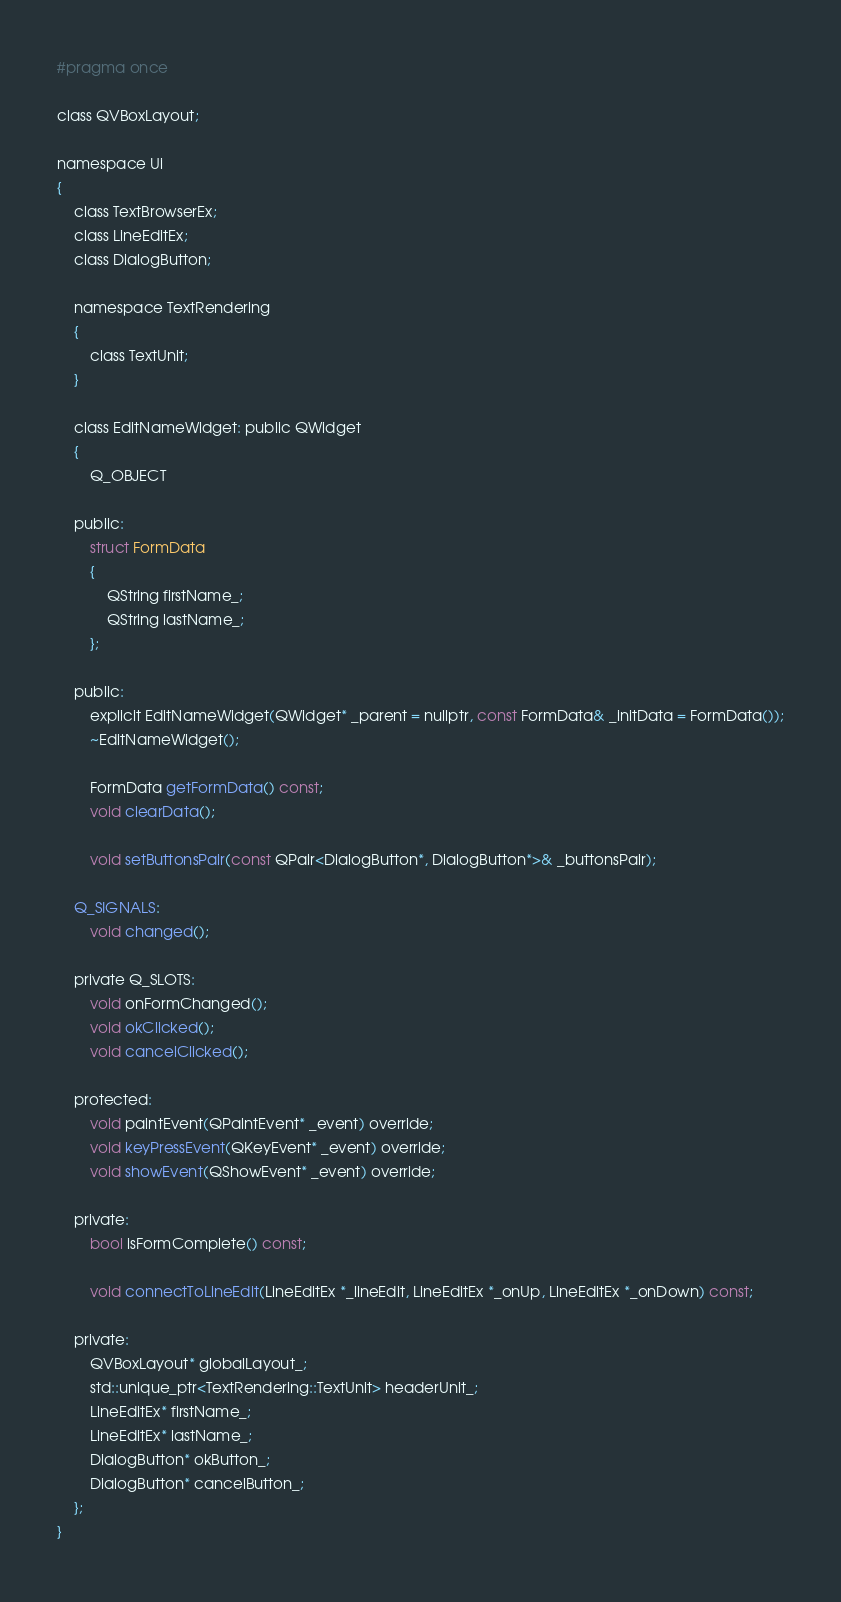<code> <loc_0><loc_0><loc_500><loc_500><_C_>#pragma once

class QVBoxLayout;

namespace Ui
{
    class TextBrowserEx;
    class LineEditEx;
    class DialogButton;

    namespace TextRendering
    {
        class TextUnit;
    }

    class EditNameWidget: public QWidget
    {
        Q_OBJECT

    public:
        struct FormData
        {
            QString firstName_;
            QString lastName_;
        };

    public:
        explicit EditNameWidget(QWidget* _parent = nullptr, const FormData& _initData = FormData());
        ~EditNameWidget();

        FormData getFormData() const;
        void clearData();

        void setButtonsPair(const QPair<DialogButton*, DialogButton*>& _buttonsPair);

    Q_SIGNALS:
        void changed();

    private Q_SLOTS:
        void onFormChanged();
        void okClicked();
        void cancelClicked();

    protected:
        void paintEvent(QPaintEvent* _event) override;
        void keyPressEvent(QKeyEvent* _event) override;
        void showEvent(QShowEvent* _event) override;

    private:
        bool isFormComplete() const;

        void connectToLineEdit(LineEditEx *_lineEdit, LineEditEx *_onUp, LineEditEx *_onDown) const;

    private:
        QVBoxLayout* globalLayout_;
        std::unique_ptr<TextRendering::TextUnit> headerUnit_;
        LineEditEx* firstName_;
        LineEditEx* lastName_;
        DialogButton* okButton_;
        DialogButton* cancelButton_;
    };
}
</code> 